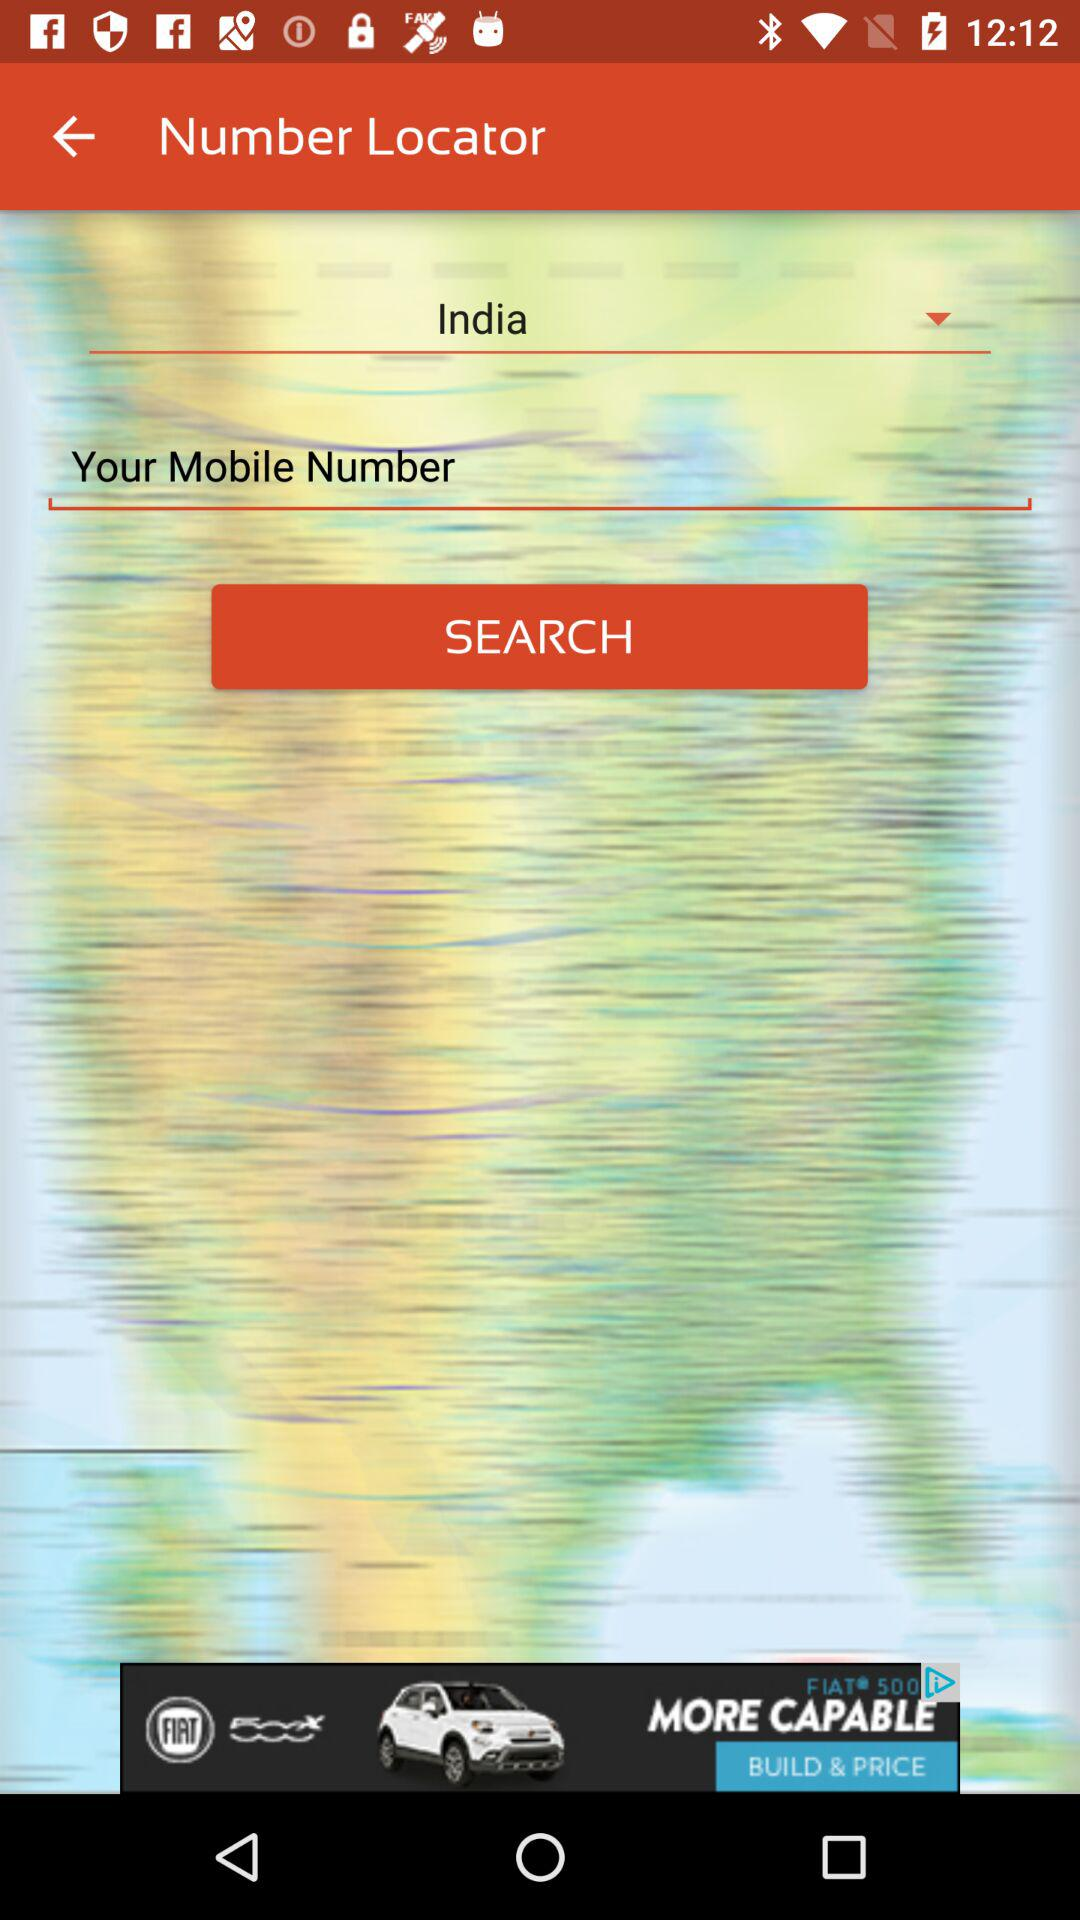What is the location? The location is India. 